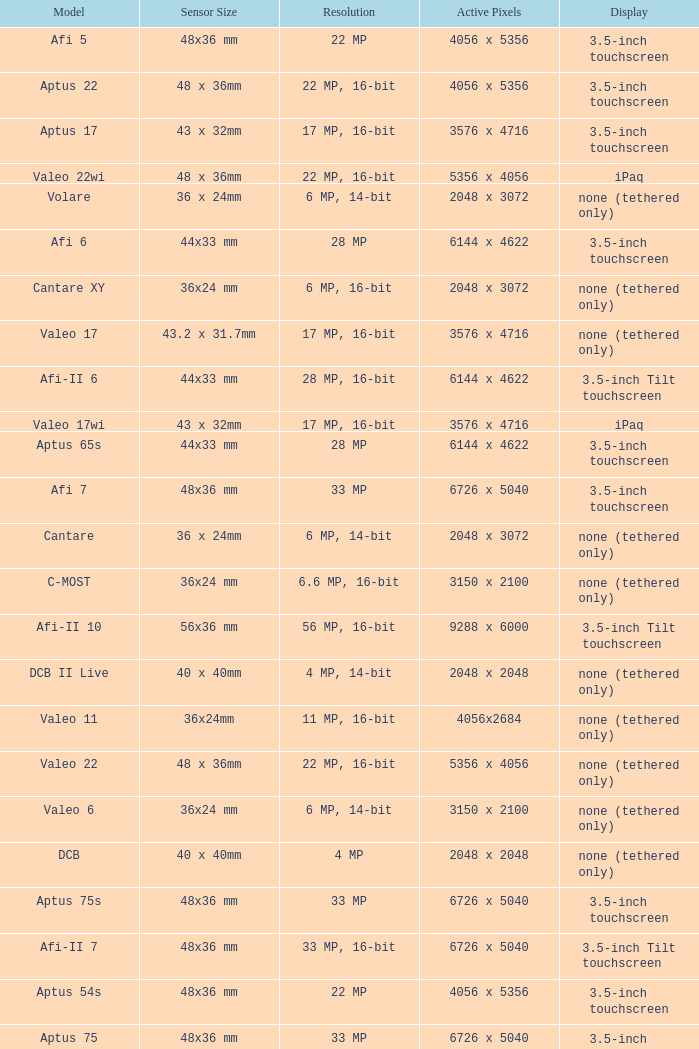Which model has a sensor sized 48x36 mm, pixels of 6726 x 5040, and a 33 mp resolution? Afi 7, Aptus 75s, Aptus 75. 